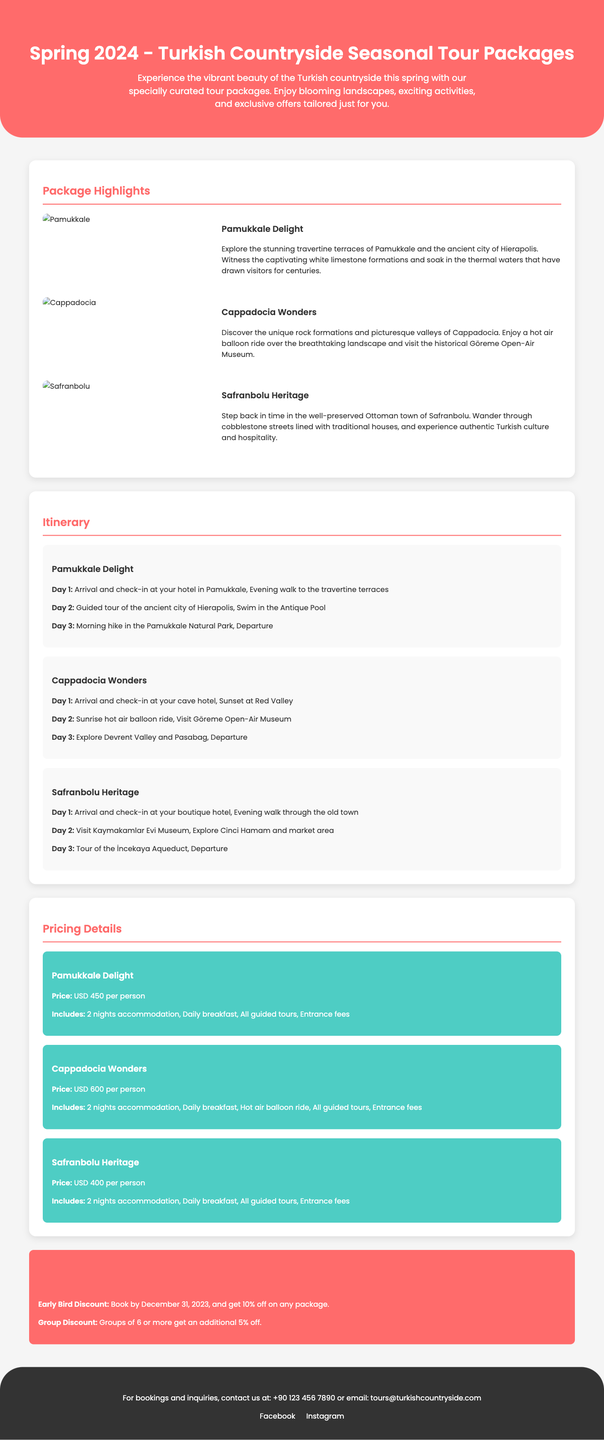What is the title of the document? The title is prominently displayed at the top of the document, indicating the focus of the content.
Answer: Spring 2024 - Turkish Countryside Seasonal Tour Packages What is the price for the Pamukkale Delight package? This information is specifically listed under the pricing details for each package.
Answer: USD 450 per person Which activity is included in the Cappadocia Wonders package? The pricing section highlights activities included with each tour package, making it easy to identify special features.
Answer: Hot air balloon ride What is the duration of the Safranbolu Heritage tour? This can be inferred from the itinerary section which details the activities planned each day, indicating the overall duration.
Answer: 3 days What discount is available for early bookings? The special offers section specifically outlines discounts that apply to bookings made by a certain date.
Answer: 10% off How many days of accommodation are included in each tour package? This is consistent across the pricing details provided for all packages.
Answer: 2 nights What is a featured location in the Pamukkale Delight package? The descriptions for each package specify unique attractions that highlight what each tour includes.
Answer: Pamukkale What is the contact method listed for inquiries? The footer of the document provides contact information for readers interested in booking or asking questions.
Answer: Email: tours@turkishcountryside.com 